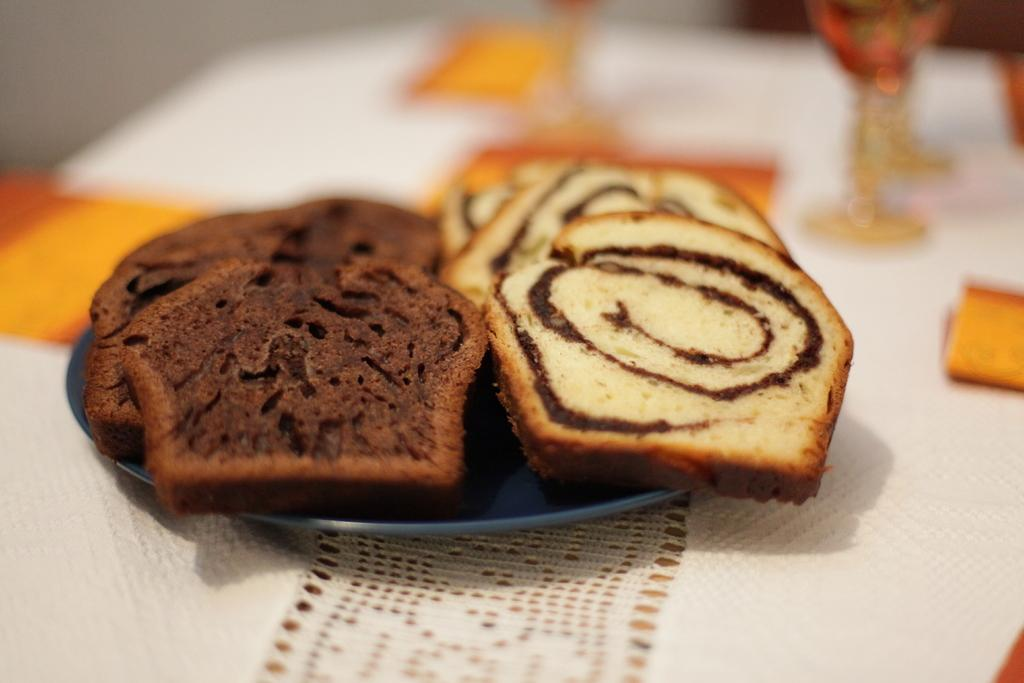What type of food can be seen in the image? The food in the image is in brown and cream colors. How is the food arranged in the image? The food is in a plate. What color is the plate? The plate is in blue color. What can be seen in the background of the image? There are glasses in the background of the image. What color is the background cloth? The background cloth is white in color. Which actor is performing on the plate in the image? There is no actor performing on the plate in the image; it is a plate of food. What type of business is being conducted on the plate in the image? There is no business being conducted on the plate in the image; it is a plate of food. 